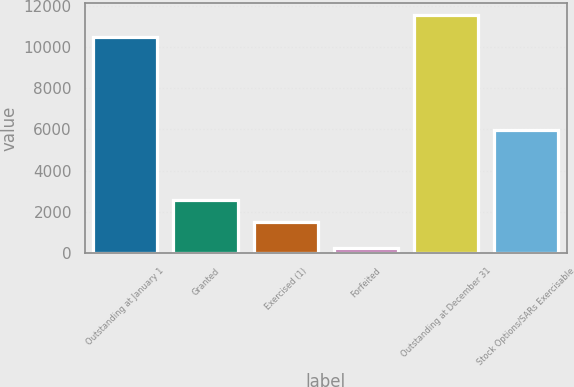<chart> <loc_0><loc_0><loc_500><loc_500><bar_chart><fcel>Outstanding at January 1<fcel>Granted<fcel>Exercised (1)<fcel>Forfeited<fcel>Outstanding at December 31<fcel>Stock Options/SARs Exercisable<nl><fcel>10493<fcel>2565.6<fcel>1518<fcel>268<fcel>11540.6<fcel>5993<nl></chart> 